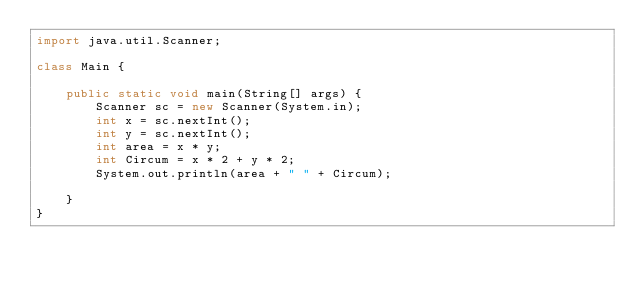<code> <loc_0><loc_0><loc_500><loc_500><_Java_>import java.util.Scanner;

class Main {
	
	public static void main(String[] args) {
		Scanner sc = new Scanner(System.in);
		int x = sc.nextInt();
		int y = sc.nextInt();
		int area = x * y;
		int Circum = x * 2 + y * 2; 
		System.out.println(area + " " + Circum);
		
	}
}</code> 